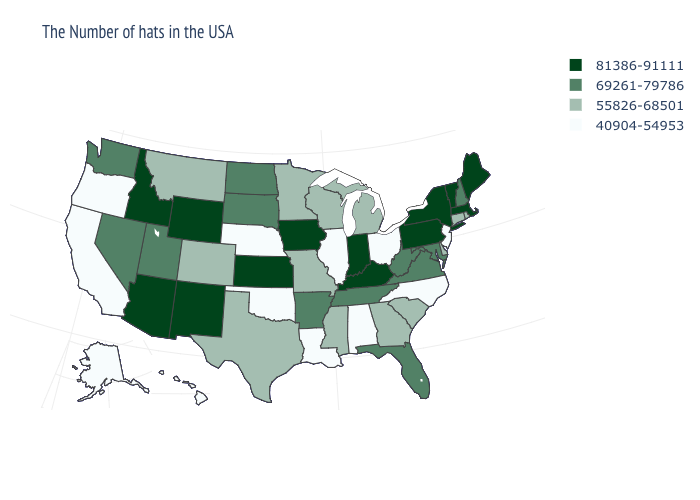Which states have the lowest value in the USA?
Answer briefly. New Jersey, North Carolina, Ohio, Alabama, Illinois, Louisiana, Nebraska, Oklahoma, California, Oregon, Alaska, Hawaii. What is the value of Virginia?
Quick response, please. 69261-79786. Which states have the lowest value in the USA?
Keep it brief. New Jersey, North Carolina, Ohio, Alabama, Illinois, Louisiana, Nebraska, Oklahoma, California, Oregon, Alaska, Hawaii. Name the states that have a value in the range 69261-79786?
Be succinct. New Hampshire, Maryland, Virginia, West Virginia, Florida, Tennessee, Arkansas, South Dakota, North Dakota, Utah, Nevada, Washington. What is the value of New York?
Be succinct. 81386-91111. Does Alabama have the lowest value in the USA?
Quick response, please. Yes. Name the states that have a value in the range 40904-54953?
Short answer required. New Jersey, North Carolina, Ohio, Alabama, Illinois, Louisiana, Nebraska, Oklahoma, California, Oregon, Alaska, Hawaii. Which states have the lowest value in the USA?
Answer briefly. New Jersey, North Carolina, Ohio, Alabama, Illinois, Louisiana, Nebraska, Oklahoma, California, Oregon, Alaska, Hawaii. How many symbols are there in the legend?
Be succinct. 4. Name the states that have a value in the range 81386-91111?
Give a very brief answer. Maine, Massachusetts, Vermont, New York, Pennsylvania, Kentucky, Indiana, Iowa, Kansas, Wyoming, New Mexico, Arizona, Idaho. Name the states that have a value in the range 40904-54953?
Keep it brief. New Jersey, North Carolina, Ohio, Alabama, Illinois, Louisiana, Nebraska, Oklahoma, California, Oregon, Alaska, Hawaii. Name the states that have a value in the range 40904-54953?
Concise answer only. New Jersey, North Carolina, Ohio, Alabama, Illinois, Louisiana, Nebraska, Oklahoma, California, Oregon, Alaska, Hawaii. What is the value of California?
Give a very brief answer. 40904-54953. Does West Virginia have the same value as Rhode Island?
Quick response, please. No. 